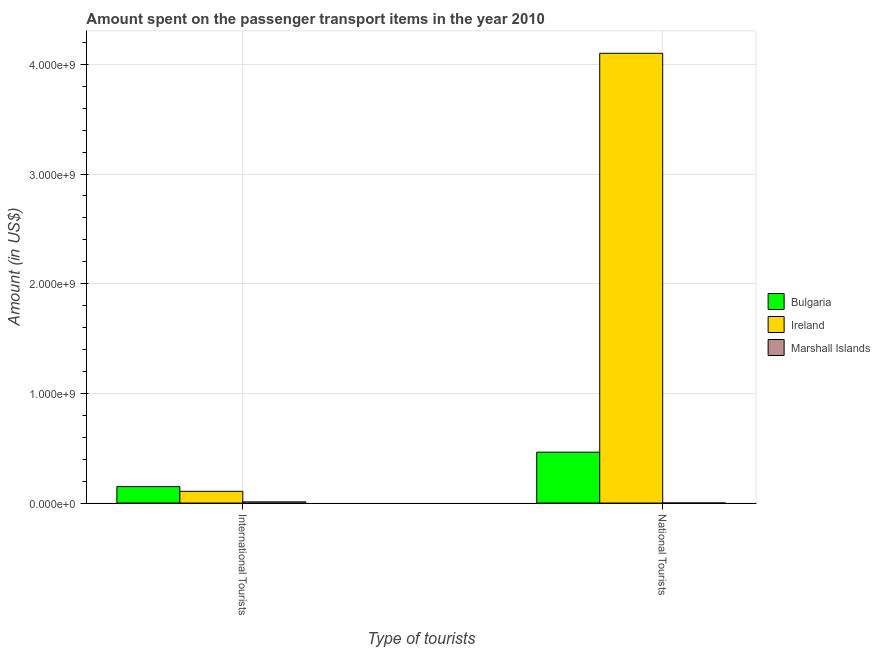How many groups of bars are there?
Your answer should be very brief. 2. Are the number of bars per tick equal to the number of legend labels?
Give a very brief answer. Yes. How many bars are there on the 1st tick from the left?
Make the answer very short. 3. How many bars are there on the 1st tick from the right?
Your response must be concise. 3. What is the label of the 2nd group of bars from the left?
Provide a succinct answer. National Tourists. What is the amount spent on transport items of international tourists in Ireland?
Your answer should be compact. 1.07e+08. Across all countries, what is the maximum amount spent on transport items of international tourists?
Make the answer very short. 1.50e+08. Across all countries, what is the minimum amount spent on transport items of international tourists?
Provide a short and direct response. 1.09e+07. In which country was the amount spent on transport items of international tourists maximum?
Your answer should be very brief. Bulgaria. In which country was the amount spent on transport items of international tourists minimum?
Make the answer very short. Marshall Islands. What is the total amount spent on transport items of national tourists in the graph?
Offer a very short reply. 4.57e+09. What is the difference between the amount spent on transport items of national tourists in Ireland and that in Marshall Islands?
Your answer should be compact. 4.10e+09. What is the difference between the amount spent on transport items of international tourists in Marshall Islands and the amount spent on transport items of national tourists in Ireland?
Provide a short and direct response. -4.09e+09. What is the average amount spent on transport items of international tourists per country?
Offer a very short reply. 8.93e+07. What is the difference between the amount spent on transport items of national tourists and amount spent on transport items of international tourists in Marshall Islands?
Ensure brevity in your answer.  -1.07e+07. What is the ratio of the amount spent on transport items of national tourists in Bulgaria to that in Marshall Islands?
Ensure brevity in your answer.  1856. Is the amount spent on transport items of international tourists in Ireland less than that in Bulgaria?
Offer a very short reply. Yes. In how many countries, is the amount spent on transport items of international tourists greater than the average amount spent on transport items of international tourists taken over all countries?
Offer a terse response. 2. What does the 2nd bar from the left in National Tourists represents?
Offer a very short reply. Ireland. What does the 3rd bar from the right in National Tourists represents?
Provide a succinct answer. Bulgaria. How many countries are there in the graph?
Your answer should be compact. 3. What is the difference between two consecutive major ticks on the Y-axis?
Your answer should be compact. 1.00e+09. Are the values on the major ticks of Y-axis written in scientific E-notation?
Make the answer very short. Yes. Does the graph contain any zero values?
Your response must be concise. No. How many legend labels are there?
Provide a succinct answer. 3. How are the legend labels stacked?
Provide a succinct answer. Vertical. What is the title of the graph?
Keep it short and to the point. Amount spent on the passenger transport items in the year 2010. What is the label or title of the X-axis?
Offer a very short reply. Type of tourists. What is the label or title of the Y-axis?
Make the answer very short. Amount (in US$). What is the Amount (in US$) of Bulgaria in International Tourists?
Your response must be concise. 1.50e+08. What is the Amount (in US$) of Ireland in International Tourists?
Ensure brevity in your answer.  1.07e+08. What is the Amount (in US$) in Marshall Islands in International Tourists?
Offer a very short reply. 1.09e+07. What is the Amount (in US$) of Bulgaria in National Tourists?
Make the answer very short. 4.64e+08. What is the Amount (in US$) of Ireland in National Tourists?
Make the answer very short. 4.10e+09. Across all Type of tourists, what is the maximum Amount (in US$) of Bulgaria?
Your response must be concise. 4.64e+08. Across all Type of tourists, what is the maximum Amount (in US$) of Ireland?
Provide a short and direct response. 4.10e+09. Across all Type of tourists, what is the maximum Amount (in US$) in Marshall Islands?
Offer a very short reply. 1.09e+07. Across all Type of tourists, what is the minimum Amount (in US$) of Bulgaria?
Keep it short and to the point. 1.50e+08. Across all Type of tourists, what is the minimum Amount (in US$) in Ireland?
Offer a very short reply. 1.07e+08. What is the total Amount (in US$) of Bulgaria in the graph?
Offer a very short reply. 6.14e+08. What is the total Amount (in US$) in Ireland in the graph?
Make the answer very short. 4.21e+09. What is the total Amount (in US$) of Marshall Islands in the graph?
Your response must be concise. 1.12e+07. What is the difference between the Amount (in US$) in Bulgaria in International Tourists and that in National Tourists?
Keep it short and to the point. -3.14e+08. What is the difference between the Amount (in US$) of Ireland in International Tourists and that in National Tourists?
Ensure brevity in your answer.  -3.99e+09. What is the difference between the Amount (in US$) in Marshall Islands in International Tourists and that in National Tourists?
Give a very brief answer. 1.07e+07. What is the difference between the Amount (in US$) of Bulgaria in International Tourists and the Amount (in US$) of Ireland in National Tourists?
Your answer should be compact. -3.95e+09. What is the difference between the Amount (in US$) of Bulgaria in International Tourists and the Amount (in US$) of Marshall Islands in National Tourists?
Offer a very short reply. 1.50e+08. What is the difference between the Amount (in US$) in Ireland in International Tourists and the Amount (in US$) in Marshall Islands in National Tourists?
Provide a succinct answer. 1.07e+08. What is the average Amount (in US$) of Bulgaria per Type of tourists?
Offer a very short reply. 3.07e+08. What is the average Amount (in US$) of Ireland per Type of tourists?
Your answer should be very brief. 2.10e+09. What is the average Amount (in US$) of Marshall Islands per Type of tourists?
Your response must be concise. 5.59e+06. What is the difference between the Amount (in US$) of Bulgaria and Amount (in US$) of Ireland in International Tourists?
Ensure brevity in your answer.  4.30e+07. What is the difference between the Amount (in US$) of Bulgaria and Amount (in US$) of Marshall Islands in International Tourists?
Give a very brief answer. 1.39e+08. What is the difference between the Amount (in US$) of Ireland and Amount (in US$) of Marshall Islands in International Tourists?
Offer a very short reply. 9.61e+07. What is the difference between the Amount (in US$) in Bulgaria and Amount (in US$) in Ireland in National Tourists?
Provide a short and direct response. -3.64e+09. What is the difference between the Amount (in US$) of Bulgaria and Amount (in US$) of Marshall Islands in National Tourists?
Offer a very short reply. 4.64e+08. What is the difference between the Amount (in US$) of Ireland and Amount (in US$) of Marshall Islands in National Tourists?
Your answer should be compact. 4.10e+09. What is the ratio of the Amount (in US$) of Bulgaria in International Tourists to that in National Tourists?
Keep it short and to the point. 0.32. What is the ratio of the Amount (in US$) of Ireland in International Tourists to that in National Tourists?
Your answer should be compact. 0.03. What is the ratio of the Amount (in US$) of Marshall Islands in International Tourists to that in National Tourists?
Ensure brevity in your answer.  43.72. What is the difference between the highest and the second highest Amount (in US$) of Bulgaria?
Offer a terse response. 3.14e+08. What is the difference between the highest and the second highest Amount (in US$) in Ireland?
Provide a succinct answer. 3.99e+09. What is the difference between the highest and the second highest Amount (in US$) of Marshall Islands?
Provide a short and direct response. 1.07e+07. What is the difference between the highest and the lowest Amount (in US$) of Bulgaria?
Keep it short and to the point. 3.14e+08. What is the difference between the highest and the lowest Amount (in US$) of Ireland?
Give a very brief answer. 3.99e+09. What is the difference between the highest and the lowest Amount (in US$) in Marshall Islands?
Your answer should be compact. 1.07e+07. 